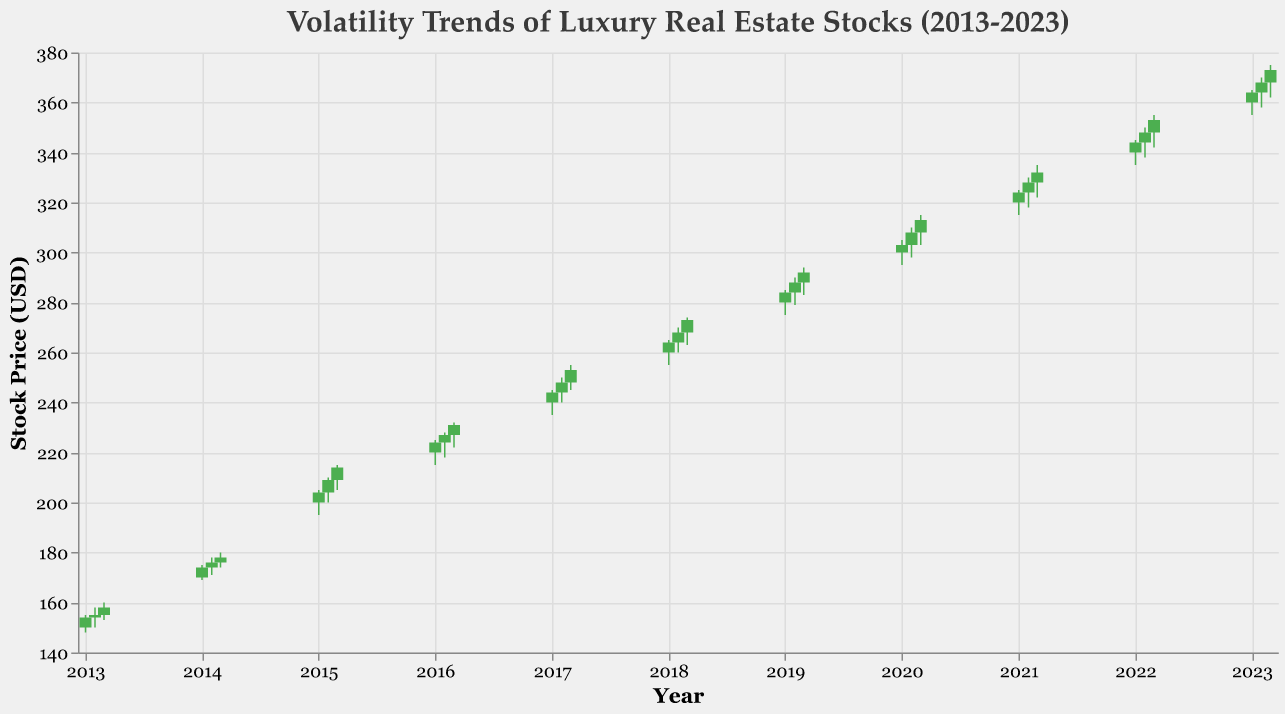How many companies are represented in the plot? The plot contains data for multiple companies over a ten-year period. We can count the occurrences of unique company names in the tooltip or legend if available. From the provided data, there are 10 unique companies: Berkshire Hathaway, The Blackstone Group, Brookfield Asset Management, Realty Income Corp, Prologis, Simon Property Group, Equity Residential, Public Storage, AvalonBay Communities, and Vornado Realty Trust.
Answer: 10 Which year shows the highest stock price for AvalonBay Communities? By looking at the y-axis values for AvalonBay Communities and matching them with the years on the x-axis, we can see the highest stock price occurs in 2021, with a high of 335 USD in March 2021.
Answer: 2021 What is the median closing price for Berkshire Hathaway from 2013-2013? Identify the closing prices for Berkshire Hathaway in the specified years: 154.00, 155.00, and 158.00 USD. Arrange these values in ascending order: 154.00, 155.00, 158.00. The median is the middle value, which is 155.00 USD.
Answer: 155.00 Which company had the largest range (difference between high and low prices) in March 2022? Review the high and low prices for March 2022 from each company: Vornado Realty Trust has highs of 355 USD and lows of 342 USD, indicating a range of 355 - 342 = 13 USD. Comparing the ranges, Vornado Realty Trust has the largest range.
Answer: Vornado Realty Trust How did the closing prices of Public Storage change from January 2020 to March 2020? Examine the closing prices for Public Storage: January 2020 (303 USD), February 2020 (308 USD), and March 2020 (313 USD). Calculate the differences: February-January = 308-303 = 5 USD, and March-February = 313-308 = 5 USD. The closing price increased consistently by 5 USD each month.
Answer: Increased by 5 USD each month What is the overall trend of the stock prices for Welltower Inc from January 2023 to March 2023? Observe the opening, high, low, and closing prices for Welltower Inc: January 2023 (Open: 360, Close: 364), February 2023 (Open: 364, Close: 368), and March 2023 (Open: 368, Close: 373). The closing prices are consistently increasing month by month.
Answer: Increasing trend Which company had the highest opening price in the first quarter of 2019? Review the opening prices for January, February, and March of 2019: Equity Residential had an opening price of 280 USD in January, 284 USD in February, and 288 USD in March. The highest opening price is in March 2019 (288 USD), from Equity Residential.
Answer: Equity Residential What was the stock price movement direction for Simon Property Group in January 2018? Compare the opening and closing prices for January 2018: the opening price was 260 USD, and the closing price was 264 USD. Since 264 > 260, the stock price moved upward.
Answer: Upward During which year did Berkshire Hathaway experience the lowest stock price among the given data points? Examine the low prices for Berkshire Hathaway from the given dates: 148 USD in January 2013, 150 USD in February 2013, and 153 USD in March 2013. The lowest price is 148 USD, which occurred in January 2013.
Answer: 2013 What is the average closing price for Realty Income Corp for the first quarter of 2016? Identify the closing prices for Realty Income Corp in January, February, and March 2016: 224 USD, 227 USD, and 231 USD. Calculate the average: (224 + 227 + 231) / 3 = 682 / 3 = 227.33 USD.
Answer: 227.33 USD 